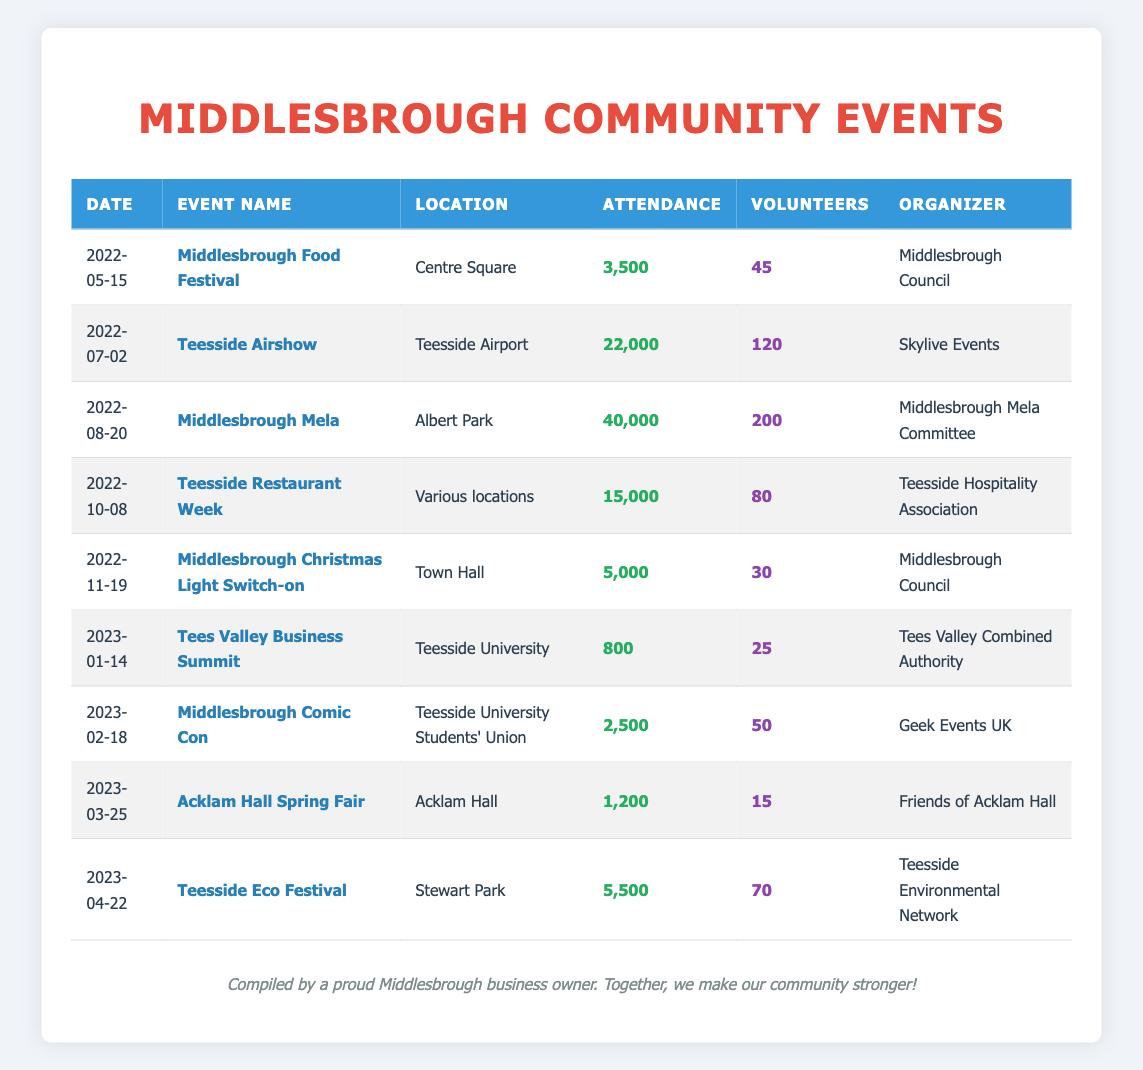What was the attendance at the Middlesbrough Mela? The Middlesbrough Mela took place on August 20, 2022, and the table shows an attendance of 40,000 people.
Answer: 40,000 How many volunteers helped at the Teesside Eco Festival? According to the table, the Teesside Eco Festival, which occurred on April 22, 2023, had 70 volunteers.
Answer: 70 What is the total attendance for all events listed? To find the total attendance, add the attendance figures from all events: 3,500 + 22,000 + 40,000 + 15,000 + 5,000 + 800 + 2,500 + 1,200 + 5,500 = 95,500.
Answer: 95,500 Which event had the highest number of volunteers? From the table, the event with the highest number of volunteers is the Middlesbrough Mela with 200 volunteers.
Answer: Middlesbrough Mela Was the attendance at the Teesside Restaurant Week greater than the attendance at Middlesbrough Food Festival? The attendance for Teesside Restaurant Week was 15,000, while the Middlesbrough Food Festival had 3,500 attendees. Since 15,000 is greater than 3,500, the answer is yes.
Answer: Yes What is the average attendance across all events? To find the average attendance, sum all attendance numbers (95,500) and divide by the number of events (9): 95,500 / 9 = 10,611.11. Therefore, the average attendance is approximately 10,611.11.
Answer: 10,611.11 Did the Teesside Airshow have more volunteers than the Middlesbrough Christmas Light Switch-on? The Teesside Airshow had 120 volunteers, while the Middlesbrough Christmas Light Switch-on had 30 volunteers. Since 120 is greater than 30, the answer is yes.
Answer: Yes What is the difference in attendance between the highest and lowest attended events? The highest attended event is the Middlesbrough Mela with 40,000 attendees, and the lowest attended event is the Tees Valley Business Summit with 800. The difference is 40,000 - 800 = 39,200.
Answer: 39,200 Which organizer had the least number of volunteers in their event? Referring to the table, the event with the least number of volunteers is the Acklam Hall Spring Fair with only 15 volunteers, organized by Friends of Acklam Hall.
Answer: Acklam Hall Spring Fair 